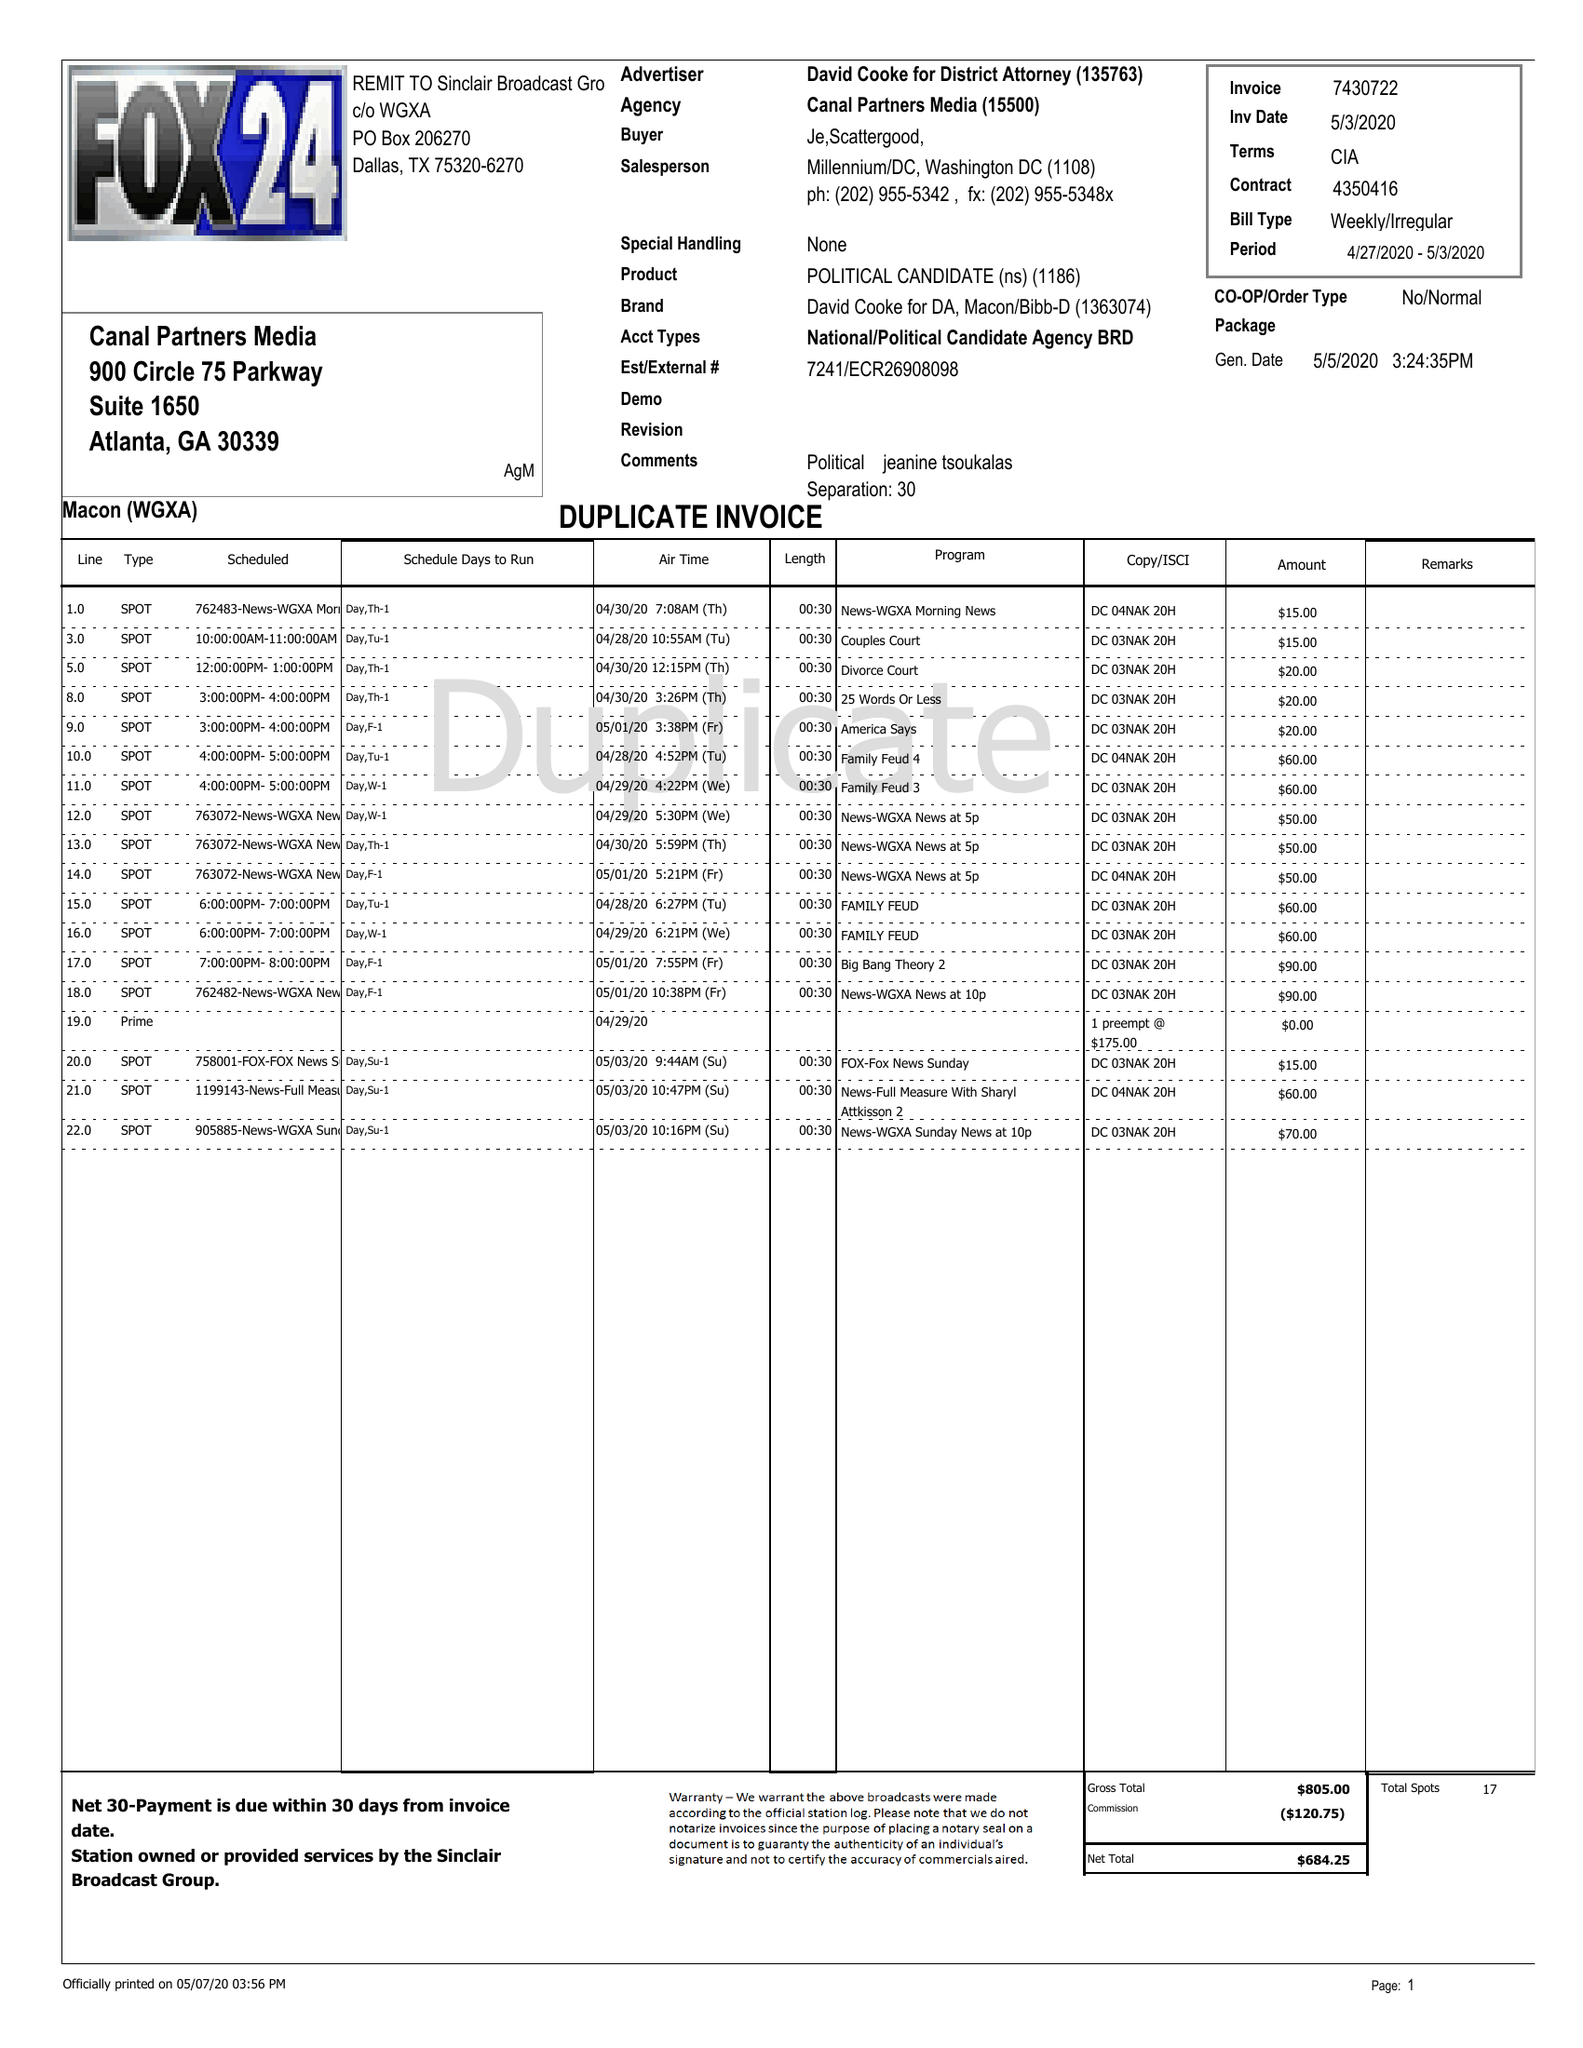What is the value for the advertiser?
Answer the question using a single word or phrase. DAVID COOKE FOR DISTRICT ATTORNEY 